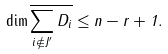<formula> <loc_0><loc_0><loc_500><loc_500>\dim \overline { \sum _ { i \not \in J ^ { \prime } } D _ { i } } \leq n - r + 1 .</formula> 